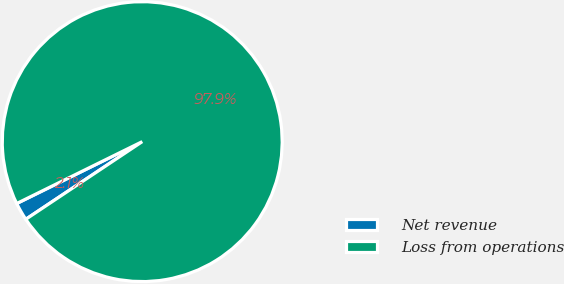Convert chart. <chart><loc_0><loc_0><loc_500><loc_500><pie_chart><fcel>Net revenue<fcel>Loss from operations<nl><fcel>2.07%<fcel>97.93%<nl></chart> 